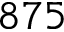Convert formula to latex. <formula><loc_0><loc_0><loc_500><loc_500>8 7 5</formula> 